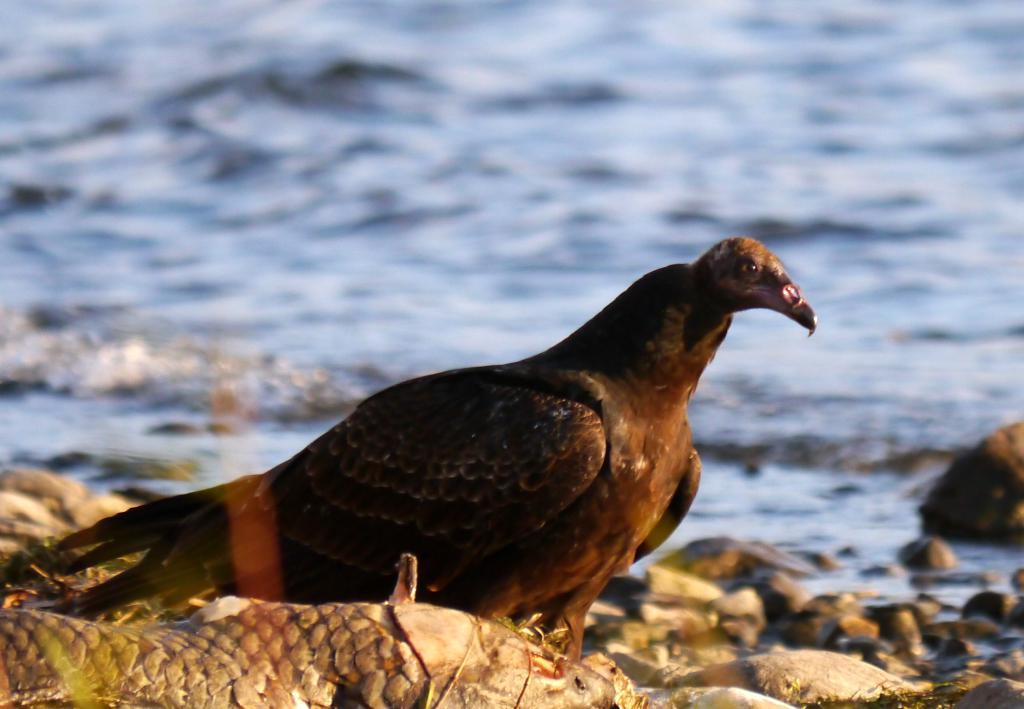What type of animal can be seen in the image? There is a bird in the image. What other animals are present in the image? There are fishes in the image. What is the primary setting of the image? There is water visible in the background of the image. Where is the crown placed on the horse in the image? There is no crown or horse present in the image. 